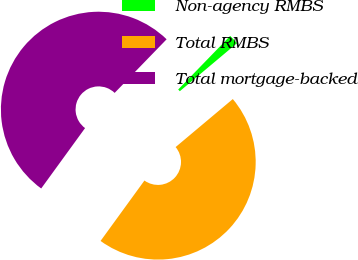Convert chart. <chart><loc_0><loc_0><loc_500><loc_500><pie_chart><fcel>Non-agency RMBS<fcel>Total RMBS<fcel>Total mortgage-backed<nl><fcel>1.63%<fcel>46.11%<fcel>52.25%<nl></chart> 